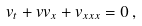<formula> <loc_0><loc_0><loc_500><loc_500>v _ { t } + v v _ { x } + v _ { x x x } = 0 \, ,</formula> 